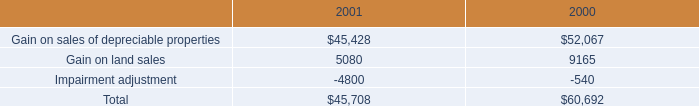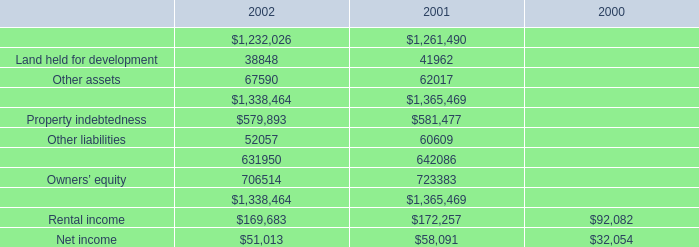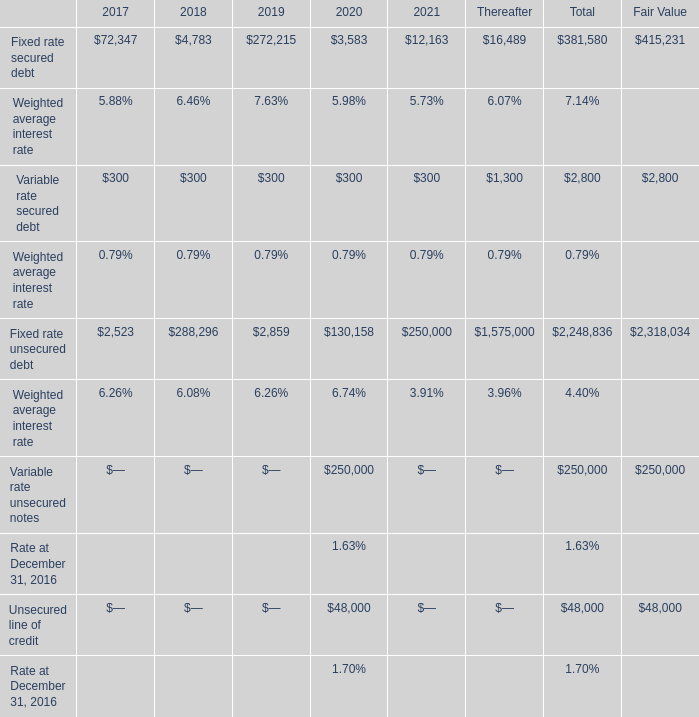what's the total amount of Owners’ equity of 2001, and Variable rate unsecured notes of Fair Value ? 
Computations: (723383.0 + 250000.0)
Answer: 973383.0. 